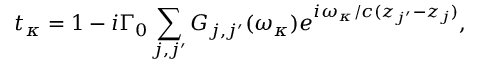Convert formula to latex. <formula><loc_0><loc_0><loc_500><loc_500>t _ { \kappa } = 1 - i { \Gamma _ { 0 } } \sum _ { j , j ^ { \prime } } { { { G _ { j , j ^ { \prime } } } ( \omega _ { \kappa } ) e ^ { i \omega _ { \kappa } / c ( { z _ { j ^ { \prime } } } - { z _ { j } } ) } } } ,</formula> 